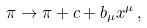Convert formula to latex. <formula><loc_0><loc_0><loc_500><loc_500>\pi \to \pi + c + b _ { \mu } x ^ { \mu } \, ,</formula> 